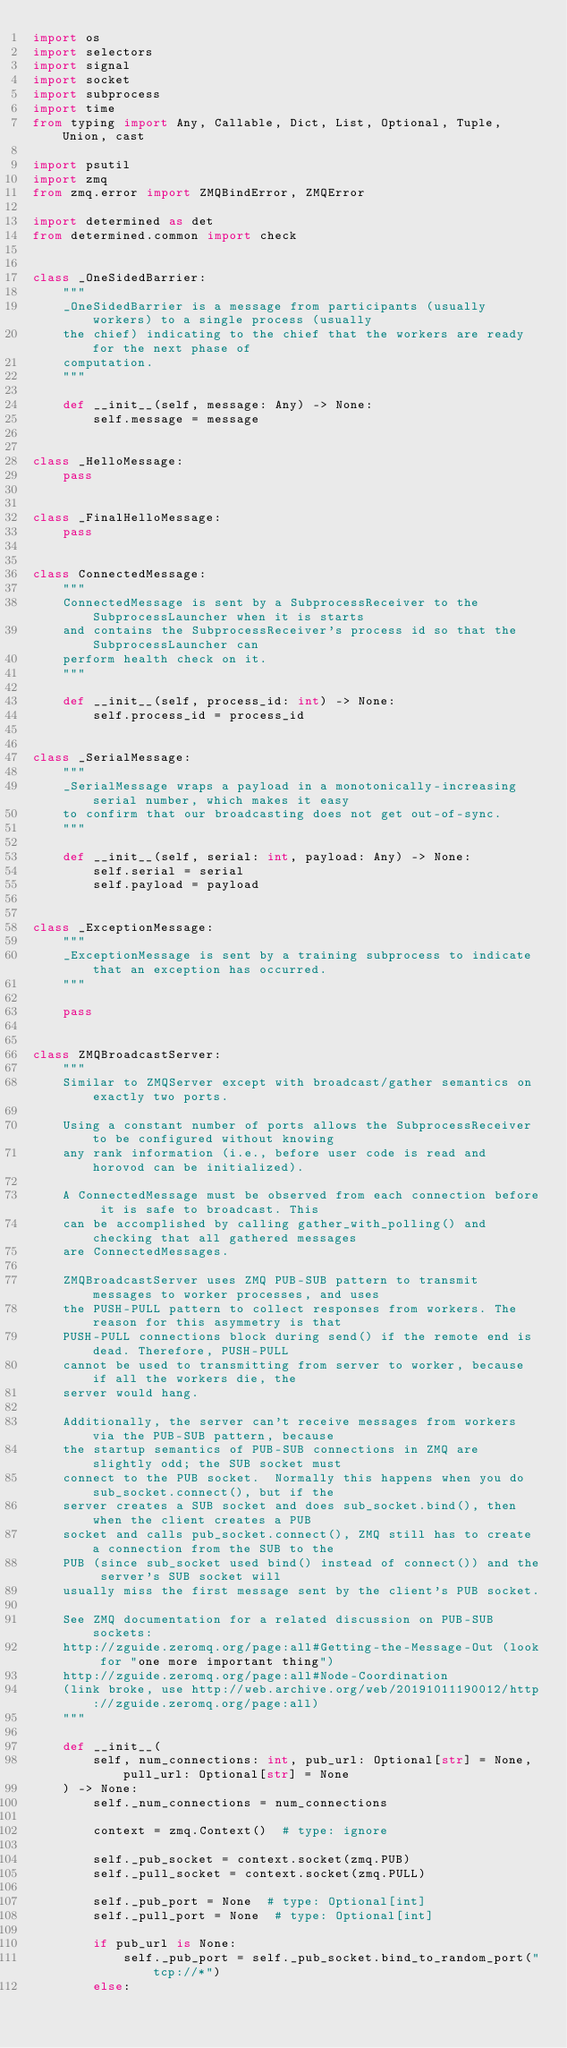Convert code to text. <code><loc_0><loc_0><loc_500><loc_500><_Python_>import os
import selectors
import signal
import socket
import subprocess
import time
from typing import Any, Callable, Dict, List, Optional, Tuple, Union, cast

import psutil
import zmq
from zmq.error import ZMQBindError, ZMQError

import determined as det
from determined.common import check


class _OneSidedBarrier:
    """
    _OneSidedBarrier is a message from participants (usually workers) to a single process (usually
    the chief) indicating to the chief that the workers are ready for the next phase of
    computation.
    """

    def __init__(self, message: Any) -> None:
        self.message = message


class _HelloMessage:
    pass


class _FinalHelloMessage:
    pass


class ConnectedMessage:
    """
    ConnectedMessage is sent by a SubprocessReceiver to the SubprocessLauncher when it is starts
    and contains the SubprocessReceiver's process id so that the SubprocessLauncher can
    perform health check on it.
    """

    def __init__(self, process_id: int) -> None:
        self.process_id = process_id


class _SerialMessage:
    """
    _SerialMessage wraps a payload in a monotonically-increasing serial number, which makes it easy
    to confirm that our broadcasting does not get out-of-sync.
    """

    def __init__(self, serial: int, payload: Any) -> None:
        self.serial = serial
        self.payload = payload


class _ExceptionMessage:
    """
    _ExceptionMessage is sent by a training subprocess to indicate that an exception has occurred.
    """

    pass


class ZMQBroadcastServer:
    """
    Similar to ZMQServer except with broadcast/gather semantics on exactly two ports.

    Using a constant number of ports allows the SubprocessReceiver to be configured without knowing
    any rank information (i.e., before user code is read and horovod can be initialized).

    A ConnectedMessage must be observed from each connection before it is safe to broadcast. This
    can be accomplished by calling gather_with_polling() and checking that all gathered messages
    are ConnectedMessages.

    ZMQBroadcastServer uses ZMQ PUB-SUB pattern to transmit messages to worker processes, and uses
    the PUSH-PULL pattern to collect responses from workers. The reason for this asymmetry is that
    PUSH-PULL connections block during send() if the remote end is dead. Therefore, PUSH-PULL
    cannot be used to transmitting from server to worker, because if all the workers die, the
    server would hang.

    Additionally, the server can't receive messages from workers via the PUB-SUB pattern, because
    the startup semantics of PUB-SUB connections in ZMQ are slightly odd; the SUB socket must
    connect to the PUB socket.  Normally this happens when you do sub_socket.connect(), but if the
    server creates a SUB socket and does sub_socket.bind(), then when the client creates a PUB
    socket and calls pub_socket.connect(), ZMQ still has to create a connection from the SUB to the
    PUB (since sub_socket used bind() instead of connect()) and the server's SUB socket will
    usually miss the first message sent by the client's PUB socket.

    See ZMQ documentation for a related discussion on PUB-SUB sockets:
    http://zguide.zeromq.org/page:all#Getting-the-Message-Out (look for "one more important thing")
    http://zguide.zeromq.org/page:all#Node-Coordination
    (link broke, use http://web.archive.org/web/20191011190012/http://zguide.zeromq.org/page:all)
    """

    def __init__(
        self, num_connections: int, pub_url: Optional[str] = None, pull_url: Optional[str] = None
    ) -> None:
        self._num_connections = num_connections

        context = zmq.Context()  # type: ignore

        self._pub_socket = context.socket(zmq.PUB)
        self._pull_socket = context.socket(zmq.PULL)

        self._pub_port = None  # type: Optional[int]
        self._pull_port = None  # type: Optional[int]

        if pub_url is None:
            self._pub_port = self._pub_socket.bind_to_random_port("tcp://*")
        else:</code> 